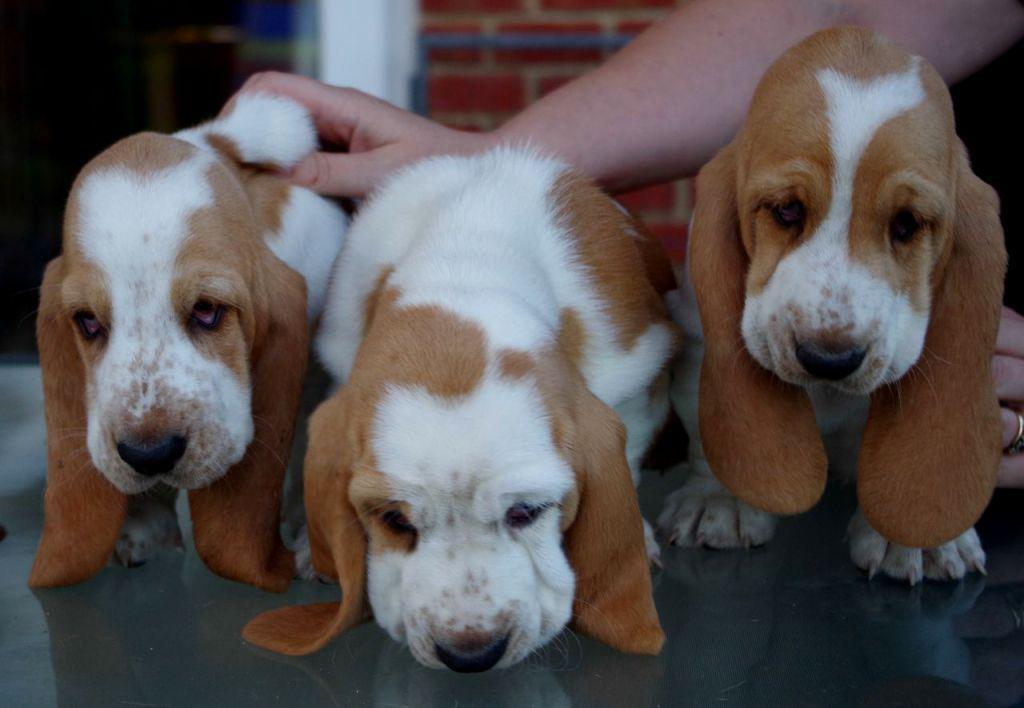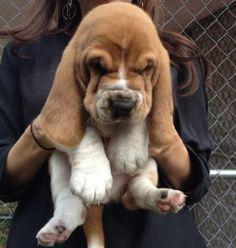The first image is the image on the left, the second image is the image on the right. Assess this claim about the two images: "At least three puppies are positioned directly next to each other in one photograph.". Correct or not? Answer yes or no. Yes. The first image is the image on the left, the second image is the image on the right. Analyze the images presented: Is the assertion "There are 4 or more dogs, and one of them is being held up by a human." valid? Answer yes or no. Yes. 